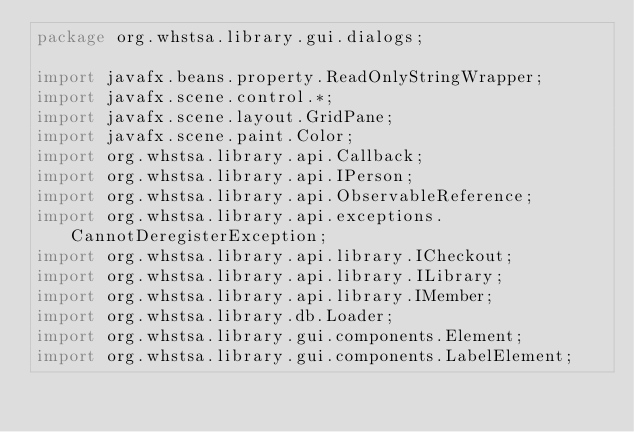Convert code to text. <code><loc_0><loc_0><loc_500><loc_500><_Java_>package org.whstsa.library.gui.dialogs;

import javafx.beans.property.ReadOnlyStringWrapper;
import javafx.scene.control.*;
import javafx.scene.layout.GridPane;
import javafx.scene.paint.Color;
import org.whstsa.library.api.Callback;
import org.whstsa.library.api.IPerson;
import org.whstsa.library.api.ObservableReference;
import org.whstsa.library.api.exceptions.CannotDeregisterException;
import org.whstsa.library.api.library.ICheckout;
import org.whstsa.library.api.library.ILibrary;
import org.whstsa.library.api.library.IMember;
import org.whstsa.library.db.Loader;
import org.whstsa.library.gui.components.Element;
import org.whstsa.library.gui.components.LabelElement;</code> 